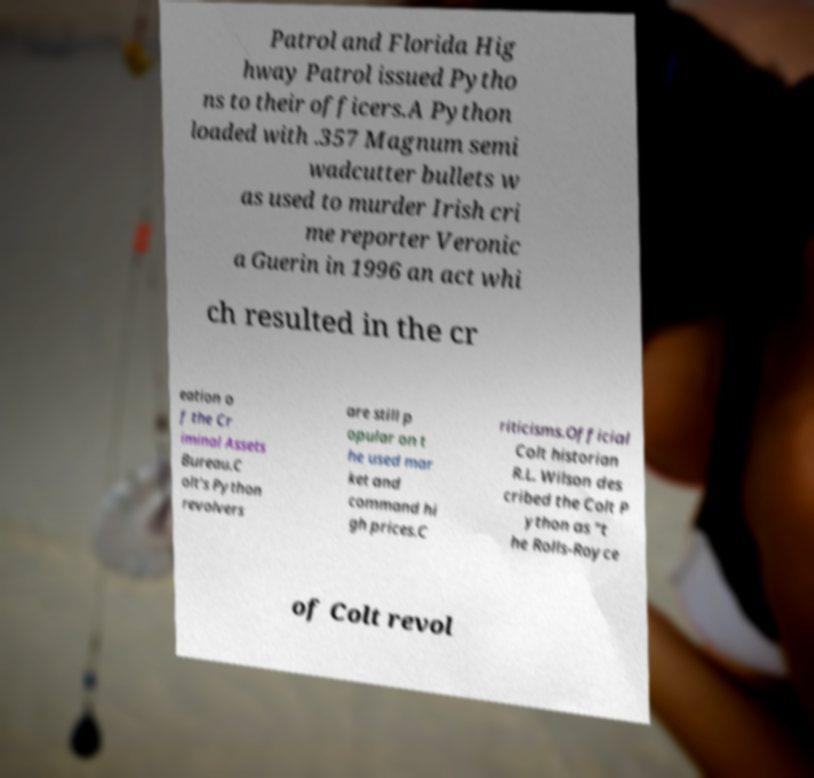Could you extract and type out the text from this image? Patrol and Florida Hig hway Patrol issued Pytho ns to their officers.A Python loaded with .357 Magnum semi wadcutter bullets w as used to murder Irish cri me reporter Veronic a Guerin in 1996 an act whi ch resulted in the cr eation o f the Cr iminal Assets Bureau.C olt's Python revolvers are still p opular on t he used mar ket and command hi gh prices.C riticisms.Official Colt historian R.L. Wilson des cribed the Colt P ython as "t he Rolls-Royce of Colt revol 